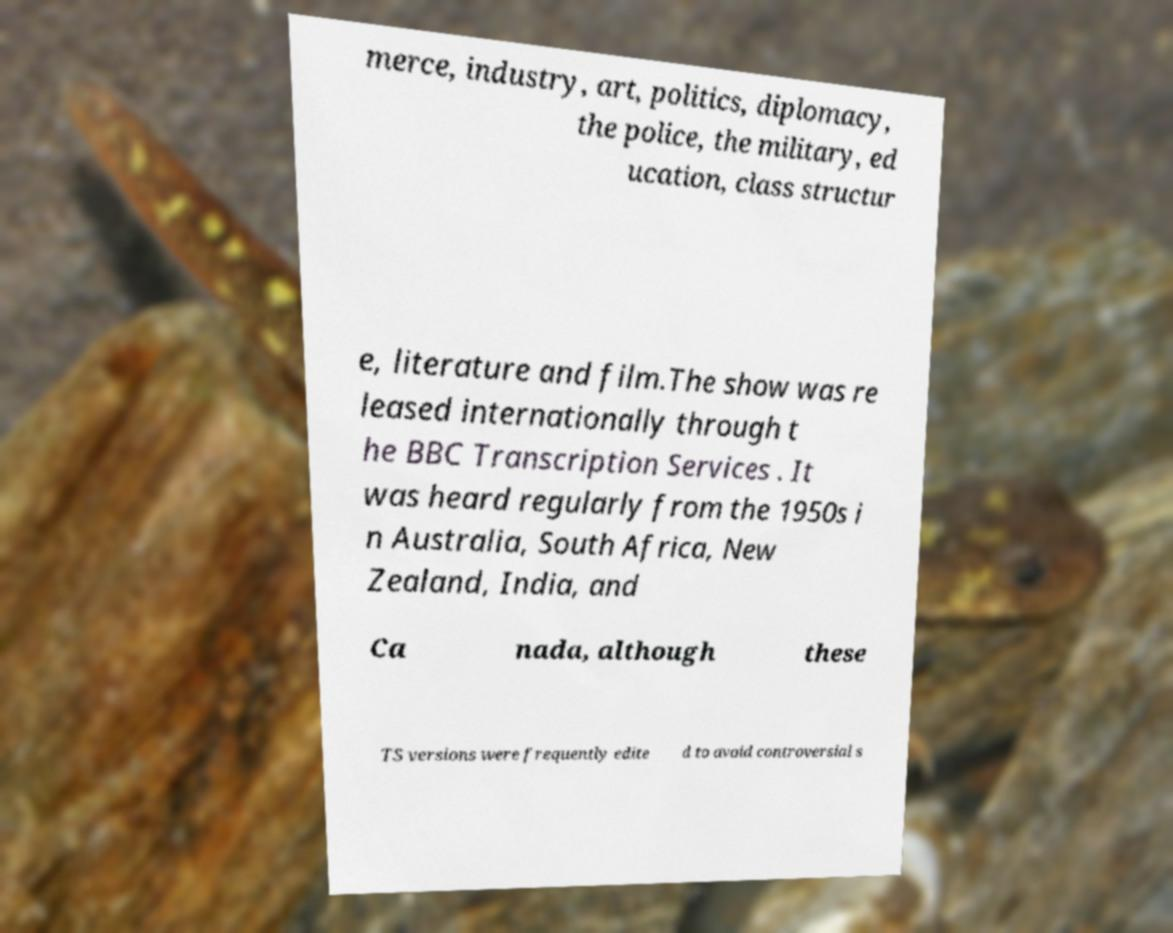Can you read and provide the text displayed in the image?This photo seems to have some interesting text. Can you extract and type it out for me? merce, industry, art, politics, diplomacy, the police, the military, ed ucation, class structur e, literature and film.The show was re leased internationally through t he BBC Transcription Services . It was heard regularly from the 1950s i n Australia, South Africa, New Zealand, India, and Ca nada, although these TS versions were frequently edite d to avoid controversial s 